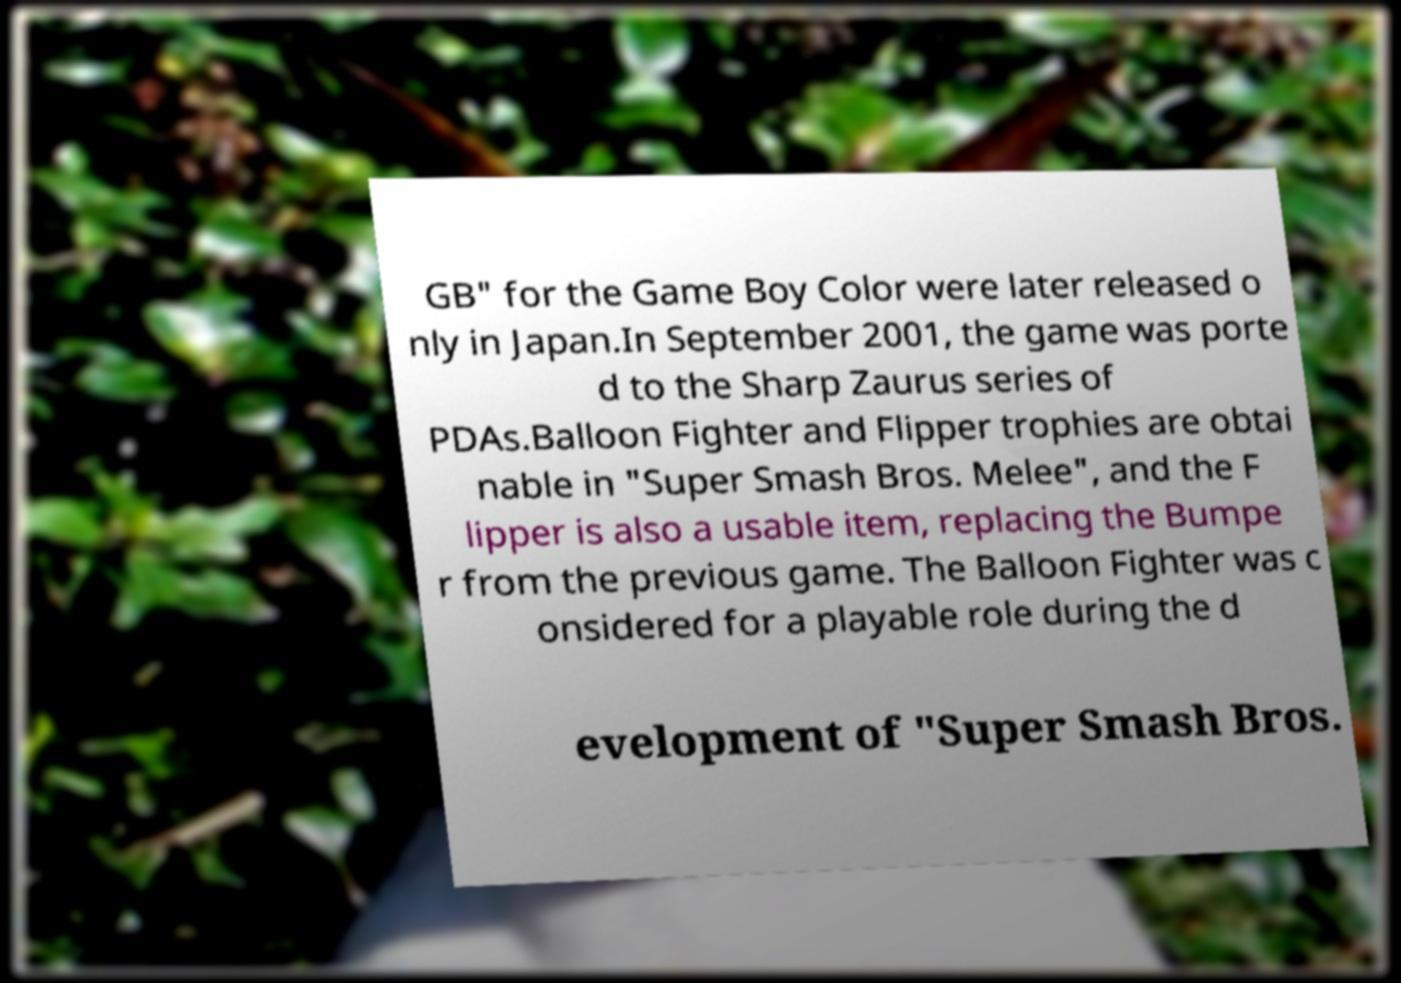What messages or text are displayed in this image? I need them in a readable, typed format. GB" for the Game Boy Color were later released o nly in Japan.In September 2001, the game was porte d to the Sharp Zaurus series of PDAs.Balloon Fighter and Flipper trophies are obtai nable in "Super Smash Bros. Melee", and the F lipper is also a usable item, replacing the Bumpe r from the previous game. The Balloon Fighter was c onsidered for a playable role during the d evelopment of "Super Smash Bros. 